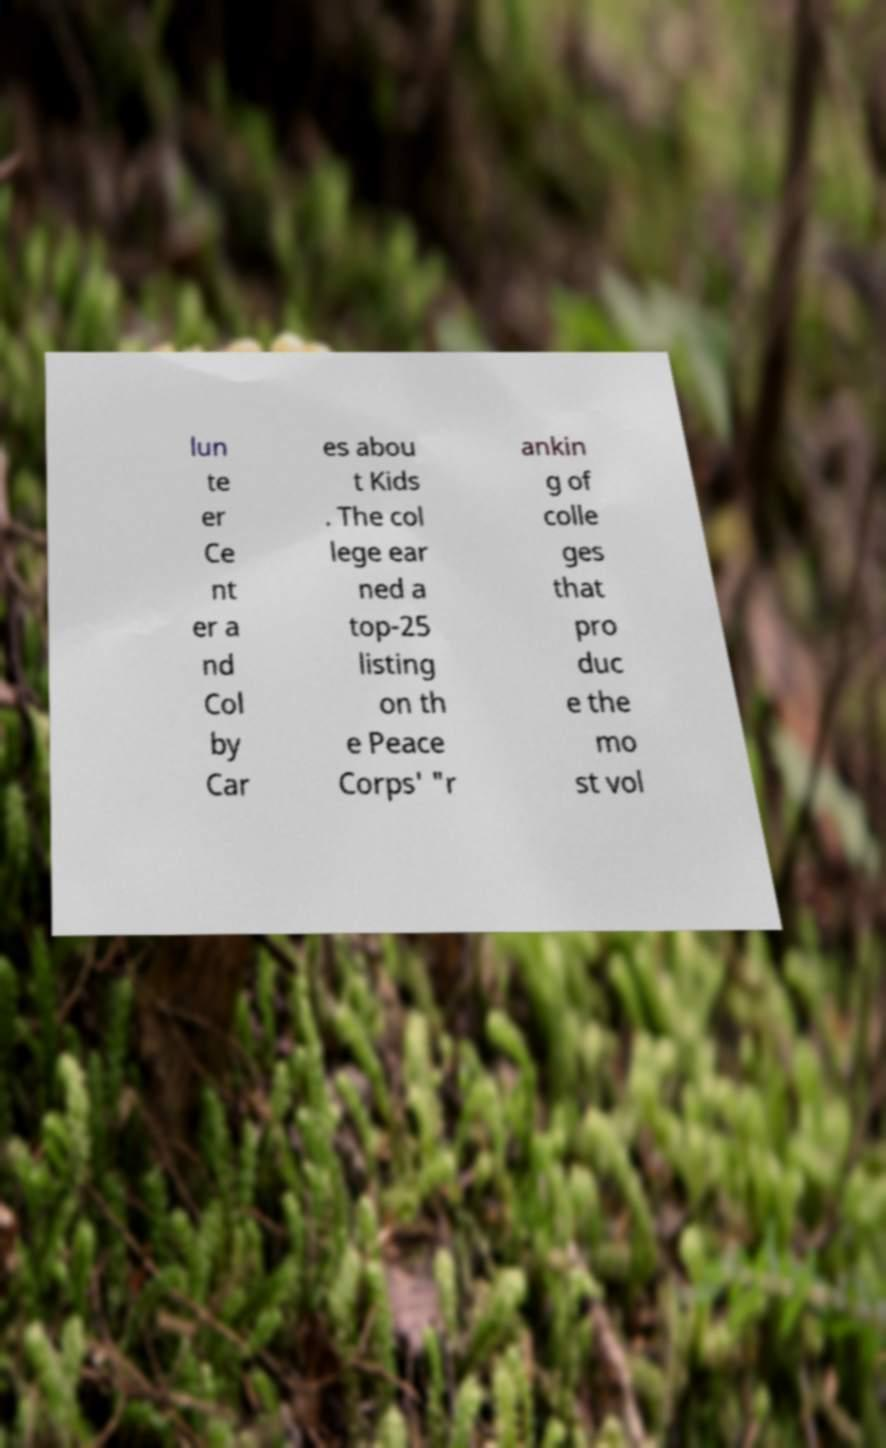Could you assist in decoding the text presented in this image and type it out clearly? lun te er Ce nt er a nd Col by Car es abou t Kids . The col lege ear ned a top-25 listing on th e Peace Corps' "r ankin g of colle ges that pro duc e the mo st vol 